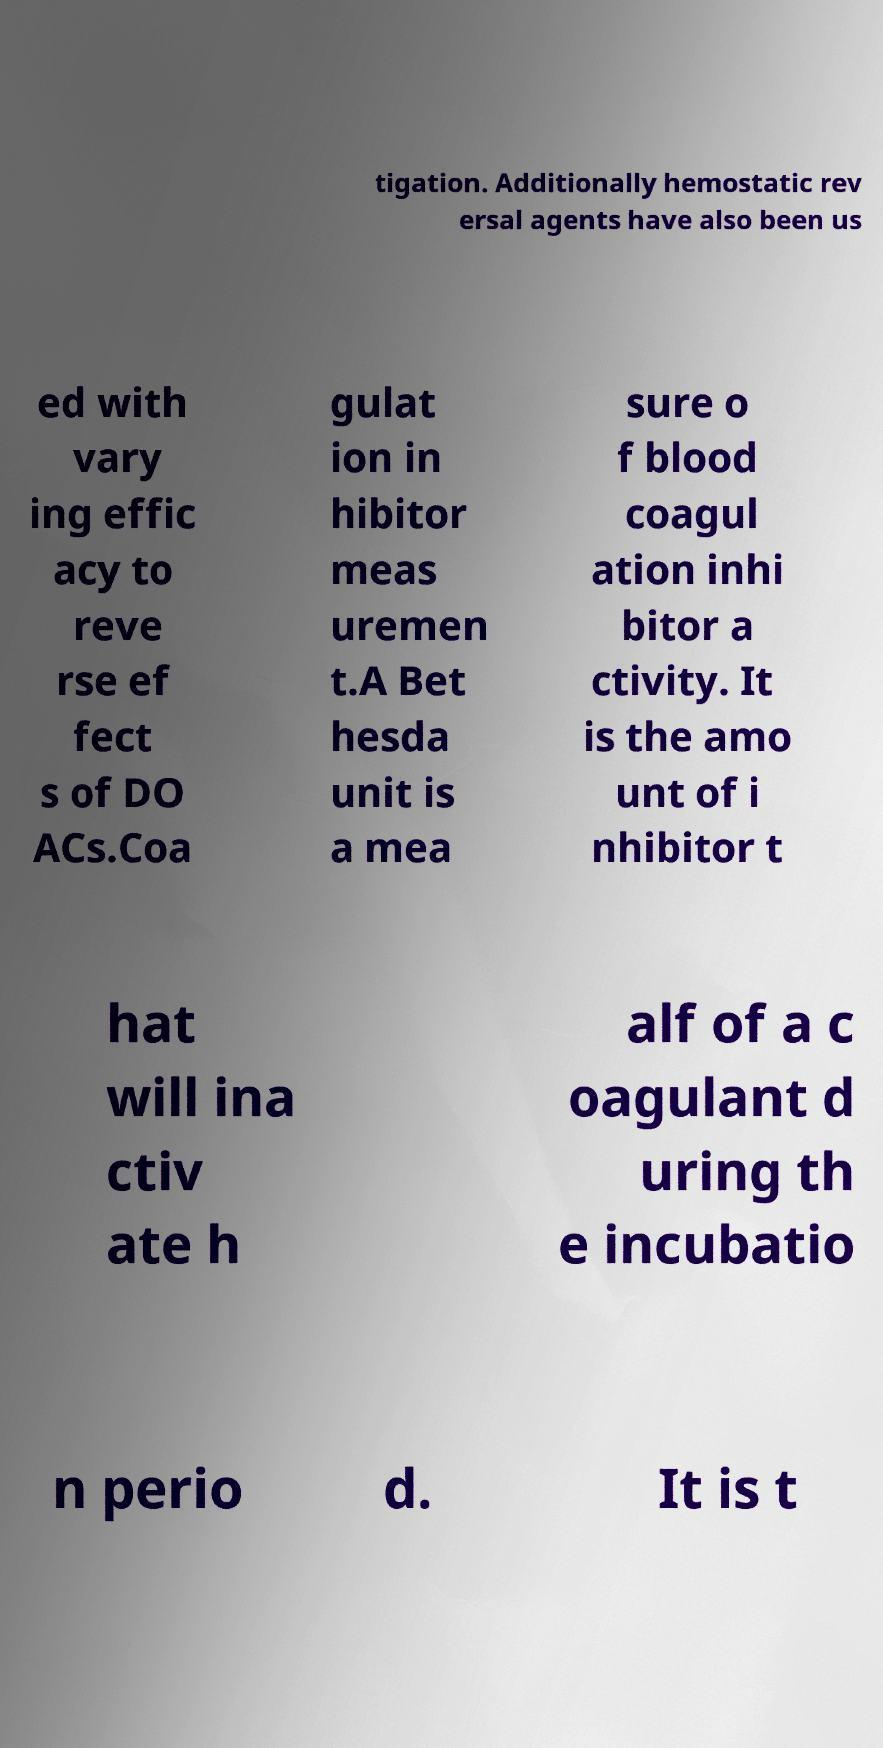Can you read and provide the text displayed in the image?This photo seems to have some interesting text. Can you extract and type it out for me? tigation. Additionally hemostatic rev ersal agents have also been us ed with vary ing effic acy to reve rse ef fect s of DO ACs.Coa gulat ion in hibitor meas uremen t.A Bet hesda unit is a mea sure o f blood coagul ation inhi bitor a ctivity. It is the amo unt of i nhibitor t hat will ina ctiv ate h alf of a c oagulant d uring th e incubatio n perio d. It is t 